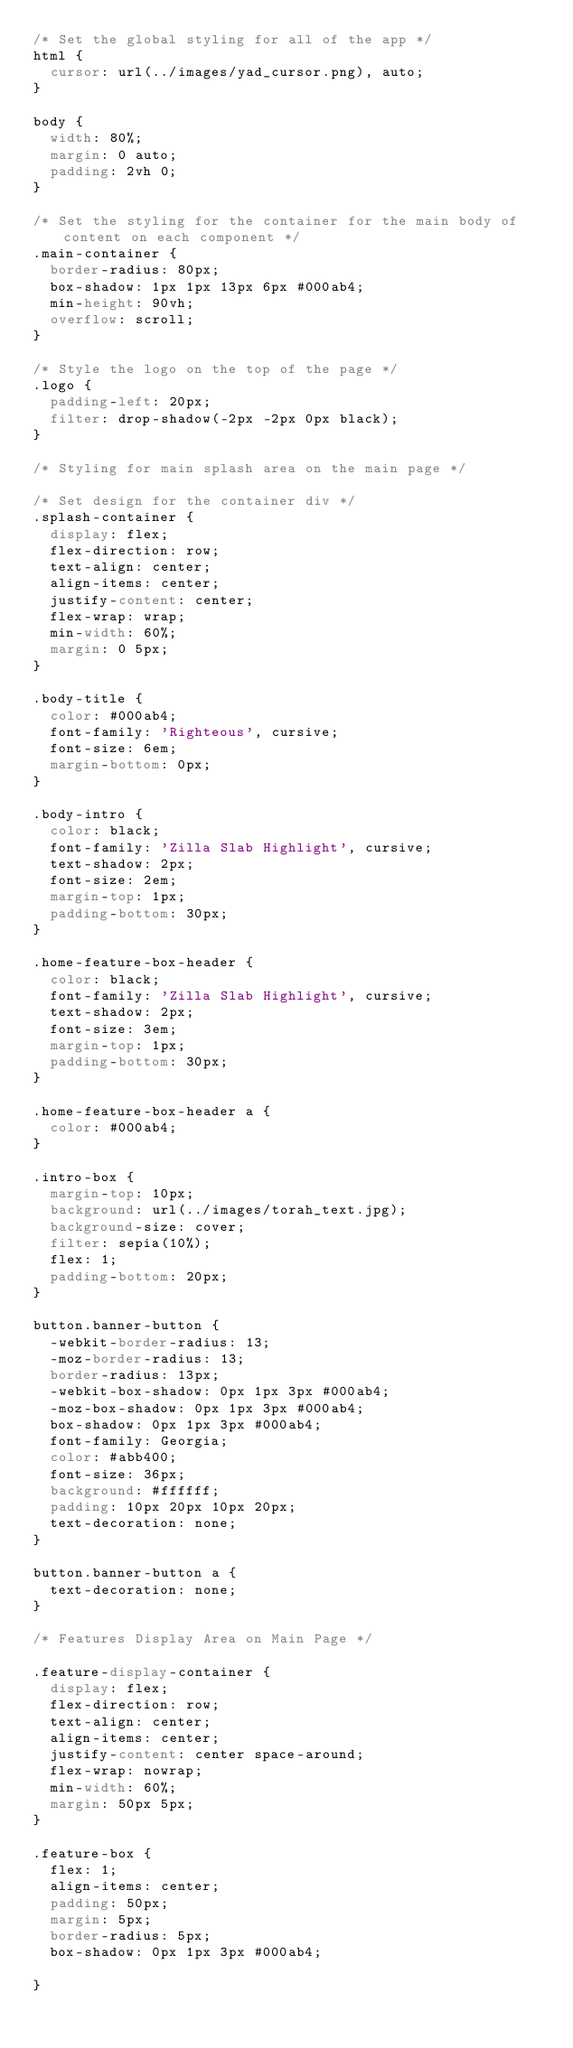Convert code to text. <code><loc_0><loc_0><loc_500><loc_500><_CSS_>/* Set the global styling for all of the app */
html {
  cursor: url(../images/yad_cursor.png), auto;
}

body {
  width: 80%;
  margin: 0 auto;
  padding: 2vh 0;
}

/* Set the styling for the container for the main body of content on each component */
.main-container {
  border-radius: 80px;
  box-shadow: 1px 1px 13px 6px #000ab4;
  min-height: 90vh;
  overflow: scroll;
}

/* Style the logo on the top of the page */
.logo {
  padding-left: 20px;
  filter: drop-shadow(-2px -2px 0px black);
}

/* Styling for main splash area on the main page */

/* Set design for the container div */
.splash-container {
  display: flex;
  flex-direction: row;
  text-align: center;
  align-items: center;
  justify-content: center;
  flex-wrap: wrap;
  min-width: 60%;
  margin: 0 5px;
}

.body-title {
  color: #000ab4;
  font-family: 'Righteous', cursive;
  font-size: 6em;
  margin-bottom: 0px;
}

.body-intro {
  color: black;
  font-family: 'Zilla Slab Highlight', cursive;
  text-shadow: 2px;
  font-size: 2em;
  margin-top: 1px;
  padding-bottom: 30px;
}

.home-feature-box-header {
  color: black;
  font-family: 'Zilla Slab Highlight', cursive;
  text-shadow: 2px;
  font-size: 3em;
  margin-top: 1px;
  padding-bottom: 30px;
}

.home-feature-box-header a {
  color: #000ab4;
}

.intro-box {
  margin-top: 10px;
  background: url(../images/torah_text.jpg);
  background-size: cover;
  filter: sepia(10%);
  flex: 1;
  padding-bottom: 20px;
}

button.banner-button {
  -webkit-border-radius: 13;
  -moz-border-radius: 13;
  border-radius: 13px;
  -webkit-box-shadow: 0px 1px 3px #000ab4;
  -moz-box-shadow: 0px 1px 3px #000ab4;
  box-shadow: 0px 1px 3px #000ab4;
  font-family: Georgia;
  color: #abb400;
  font-size: 36px;
  background: #ffffff;
  padding: 10px 20px 10px 20px;
  text-decoration: none;
}

button.banner-button a {
  text-decoration: none;
}

/* Features Display Area on Main Page */

.feature-display-container {
  display: flex;
  flex-direction: row;
  text-align: center;
  align-items: center;
  justify-content: center space-around;
  flex-wrap: nowrap;
  min-width: 60%;
  margin: 50px 5px;
}

.feature-box {
  flex: 1;
  align-items: center;
  padding: 50px;
  margin: 5px;
  border-radius: 5px;
  box-shadow: 0px 1px 3px #000ab4;

}
</code> 